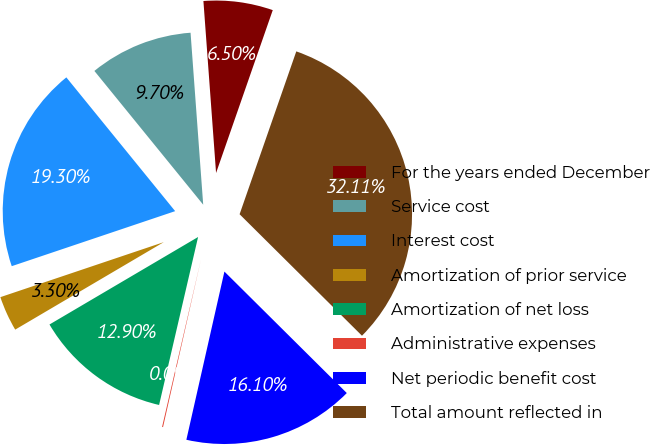Convert chart to OTSL. <chart><loc_0><loc_0><loc_500><loc_500><pie_chart><fcel>For the years ended December<fcel>Service cost<fcel>Interest cost<fcel>Amortization of prior service<fcel>Amortization of net loss<fcel>Administrative expenses<fcel>Net periodic benefit cost<fcel>Total amount reflected in<nl><fcel>6.5%<fcel>9.7%<fcel>19.3%<fcel>3.3%<fcel>12.9%<fcel>0.09%<fcel>16.1%<fcel>32.11%<nl></chart> 